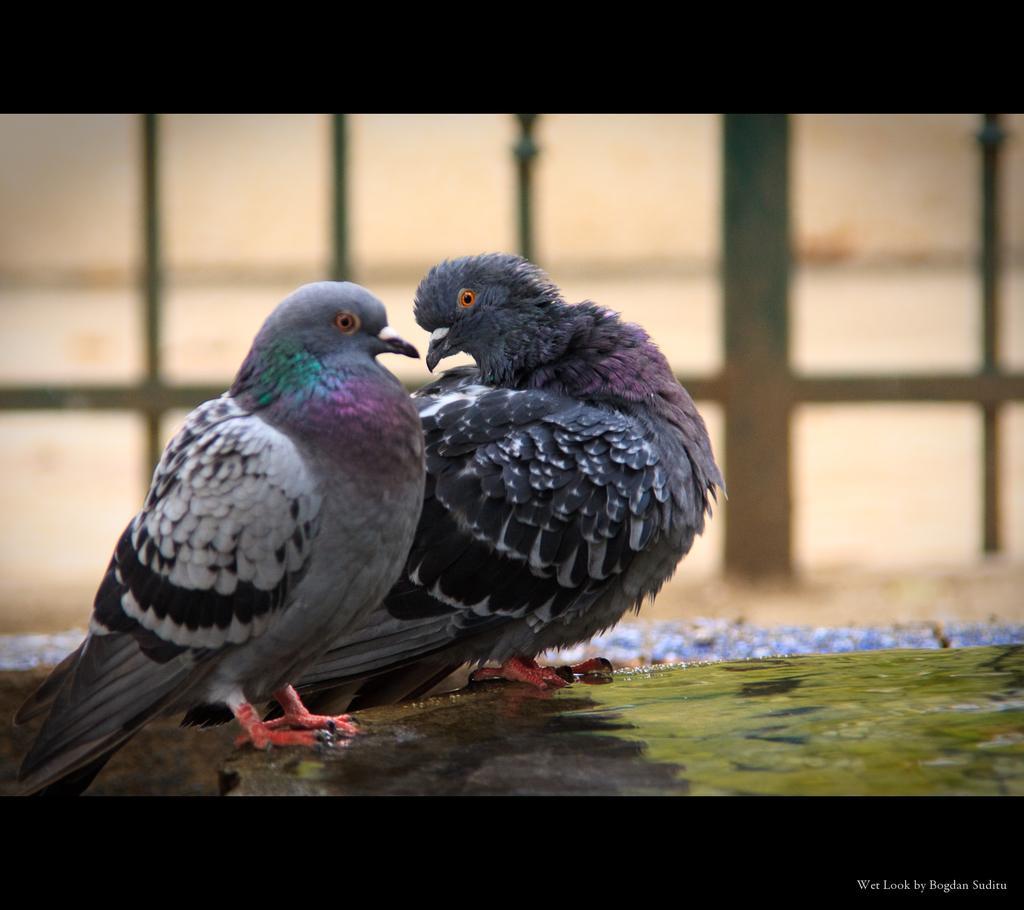In one or two sentences, can you explain what this image depicts? In this picture we can see two doves are standing, we can see a blurry background we can also see grilles in the background, there is some text at the right bottom of the image. 